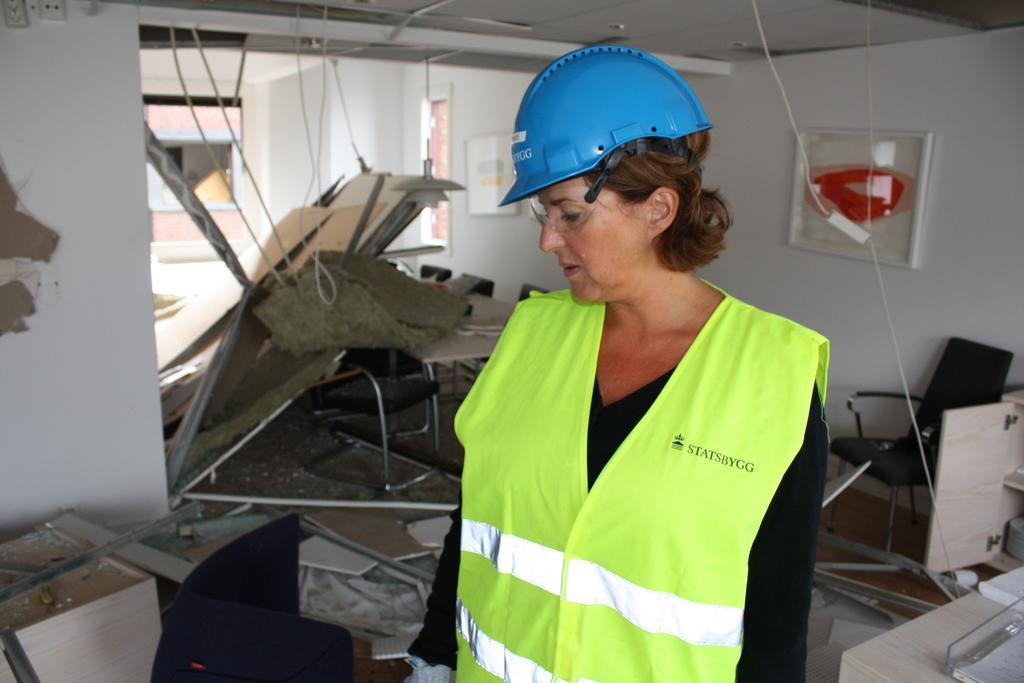How would you summarize this image in a sentence or two? In the center we can see the lady she is wearing helmet. And coming to the background they were few chairs and some wooden materials. The right corner we can see the table. 